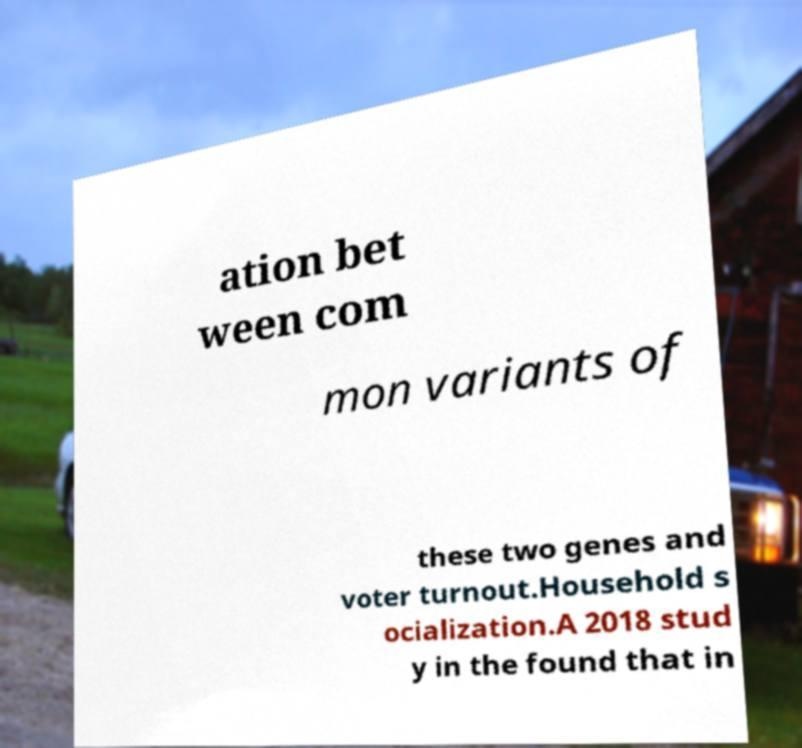For documentation purposes, I need the text within this image transcribed. Could you provide that? ation bet ween com mon variants of these two genes and voter turnout.Household s ocialization.A 2018 stud y in the found that in 